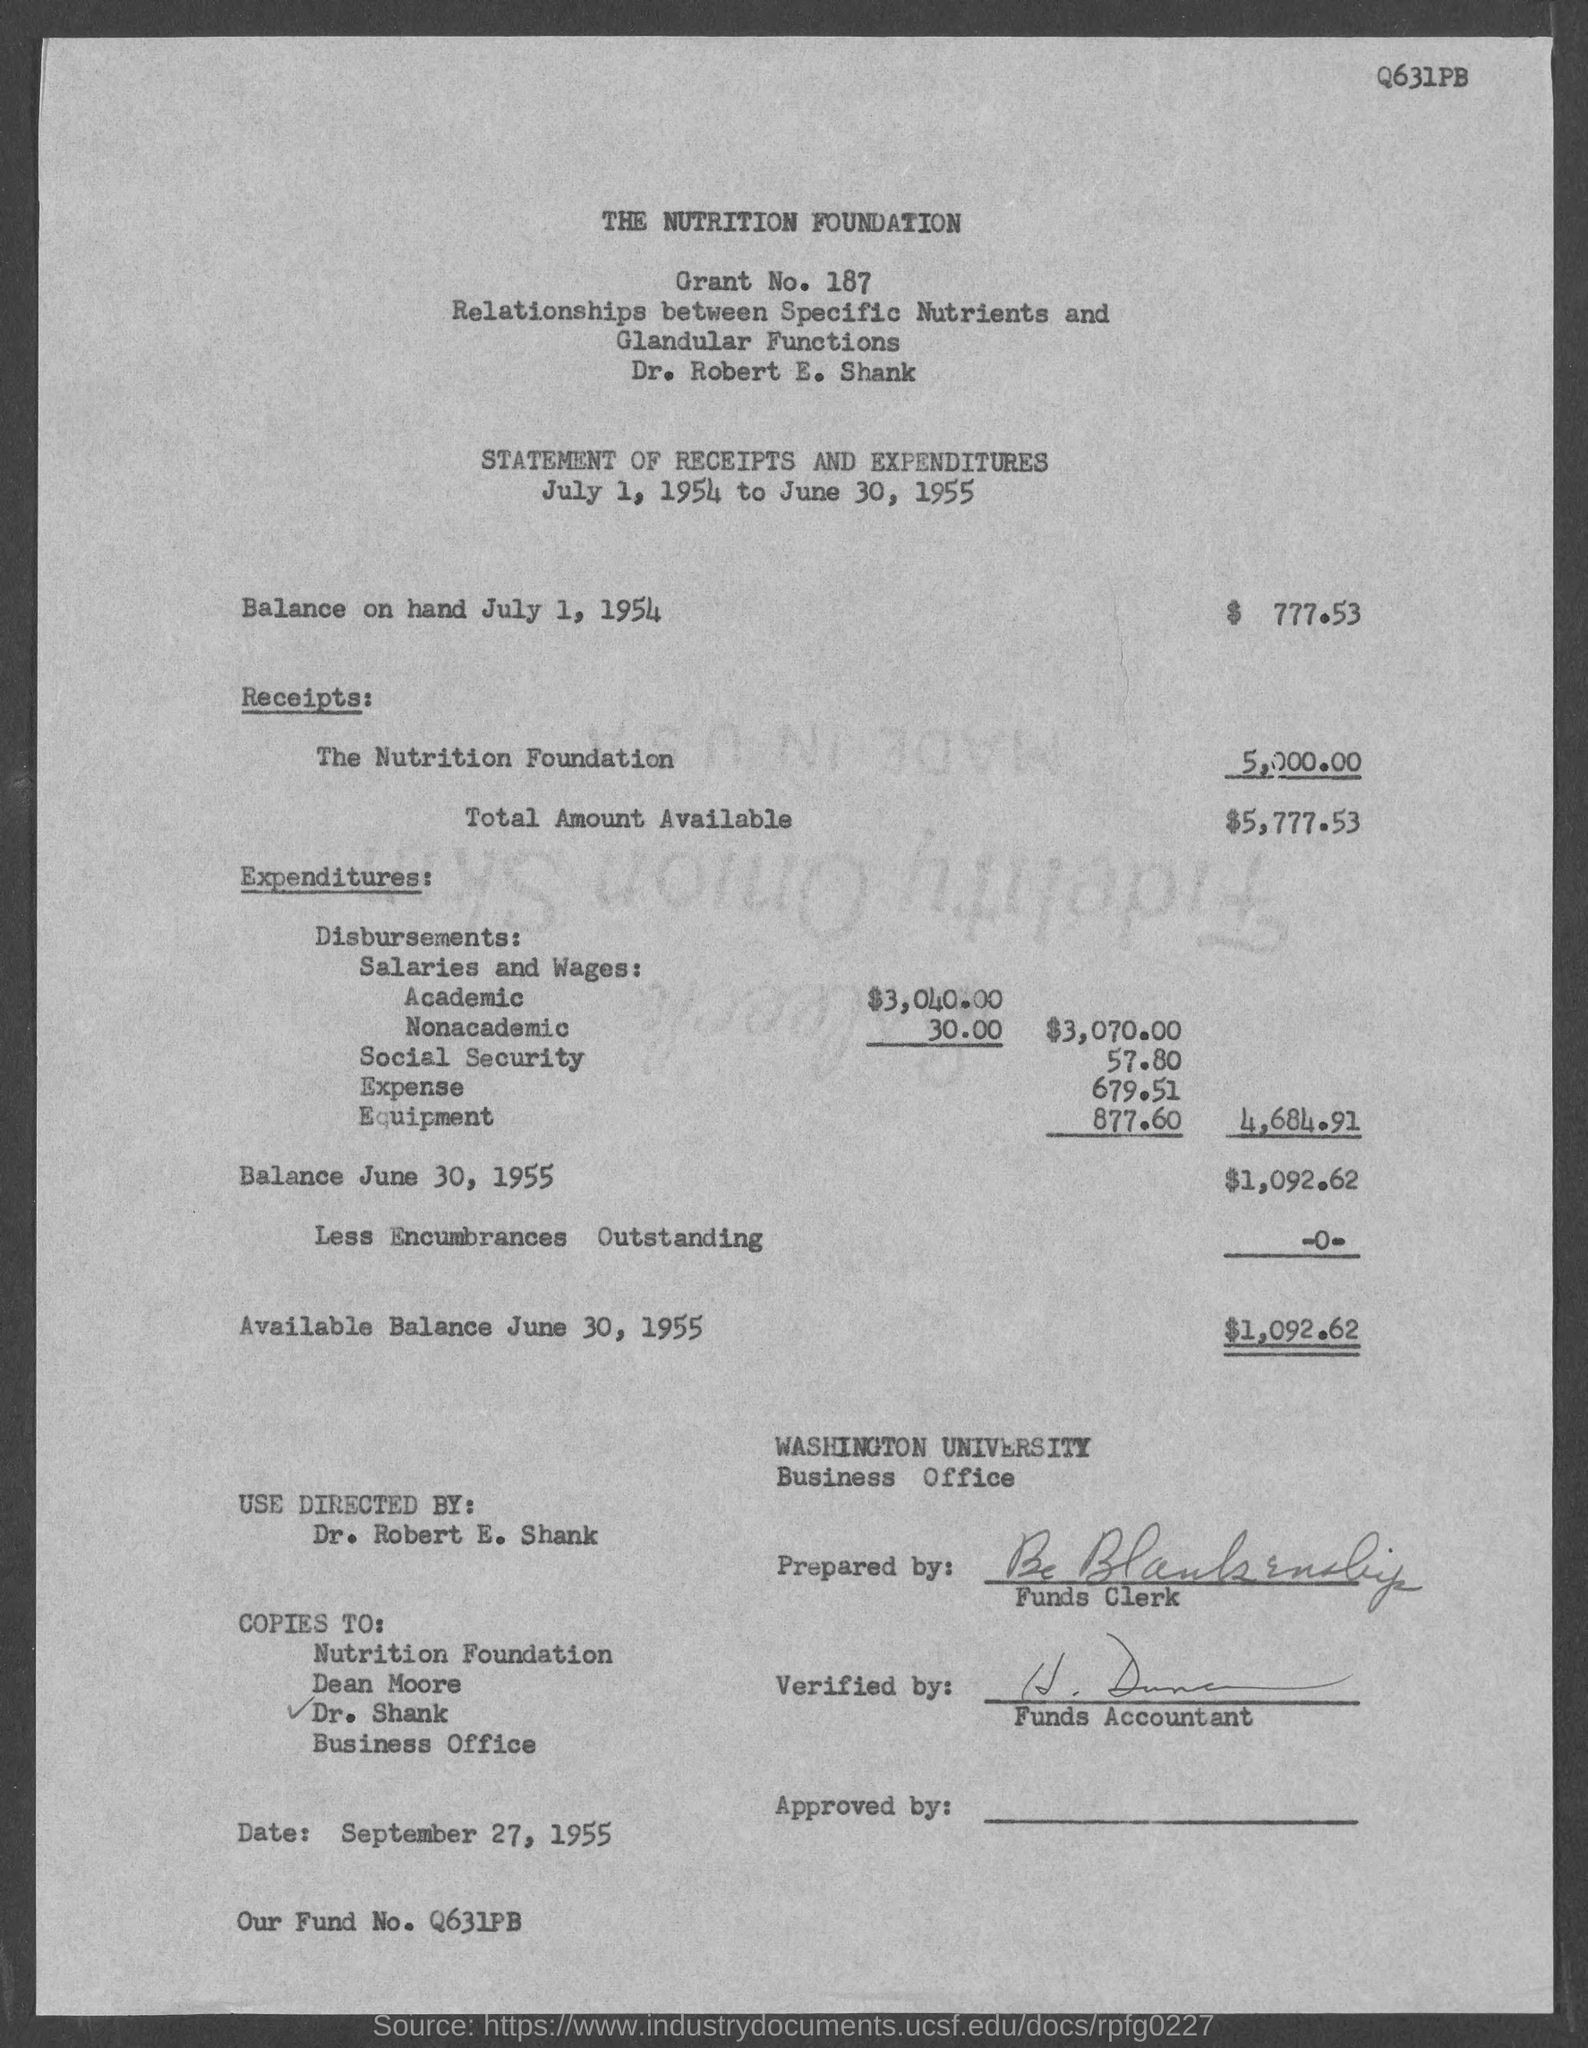What is the name of Company?
Your answer should be compact. The Nutrition Foundation. What is the total amount available
Make the answer very short. $5,777.53. What is the balance on hand by july 1,1954
Make the answer very short. $ 777.53. What is the available balance by june 30, 1955
Offer a terse response. 1,092.62. What is the university name
Offer a very short reply. WASHINGTON UNIVERSITY. What is the fund number
Make the answer very short. Q631PB. 